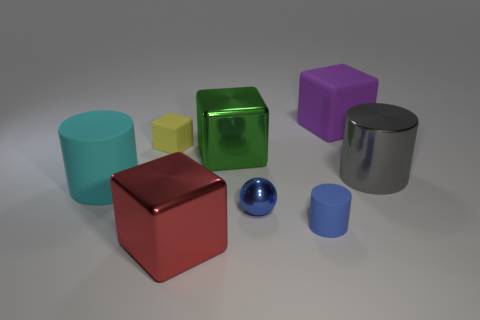Subtract all rubber cylinders. How many cylinders are left? 1 Subtract all purple blocks. How many blocks are left? 3 Subtract all cylinders. How many objects are left? 5 Subtract 1 cubes. How many cubes are left? 3 Add 5 large brown metallic cubes. How many large brown metallic cubes exist? 5 Add 1 purple things. How many objects exist? 9 Subtract 0 brown cubes. How many objects are left? 8 Subtract all blue blocks. Subtract all yellow balls. How many blocks are left? 4 Subtract all brown cubes. How many yellow balls are left? 0 Subtract all big metal cubes. Subtract all big cyan objects. How many objects are left? 5 